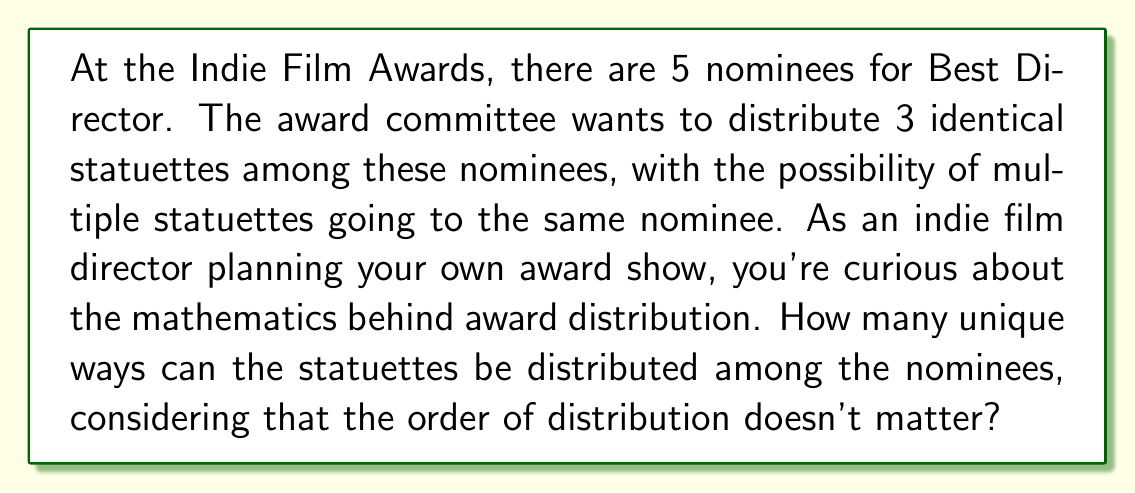Solve this math problem. Let's approach this problem using group action principles:

1) First, we need to recognize that this is a problem of distributing indistinguishable objects (the statuettes) into distinguishable boxes (the nominees). This is equivalent to finding the number of orbits under the action of the symmetric group $S_3$ on the set of functions from $\{1,2,3\}$ to $\{1,2,3,4,5\}$.

2) We can use Burnside's lemma to solve this. Burnside's lemma states that the number of orbits is equal to the average number of elements fixed by each permutation in the group.

3) The symmetric group $S_3$ has 6 elements: 
   - The identity permutation (fixes all distributions)
   - Three 2-cycles (each fixes distributions where two specific statuettes are in the same place)
   - Two 3-cycles (fix no distributions unless all statuettes are given to the same nominee)

4) Let's count the number of fixed points for each type of permutation:
   - Identity: All $5^3 = 125$ distributions are fixed.
   - 2-cycles: There are $5^2 = 25$ distributions fixed by each 2-cycle (two statuettes must go to the same nominee, the third can go anywhere).
   - 3-cycles: There are 5 distributions fixed by each 3-cycle (all statuettes must go to the same nominee).

5) Applying Burnside's lemma:

   $$\text{Number of orbits} = \frac{1}{|G|}\sum_{g \in G} |\text{Fix}(g)|$$

   $$= \frac{1}{6}(125 + 25 + 25 + 25 + 5 + 5)$$

   $$= \frac{1}{6}(210) = 35$$

Thus, there are 35 unique ways to distribute the statuettes among the nominees.
Answer: 35 unique ways 